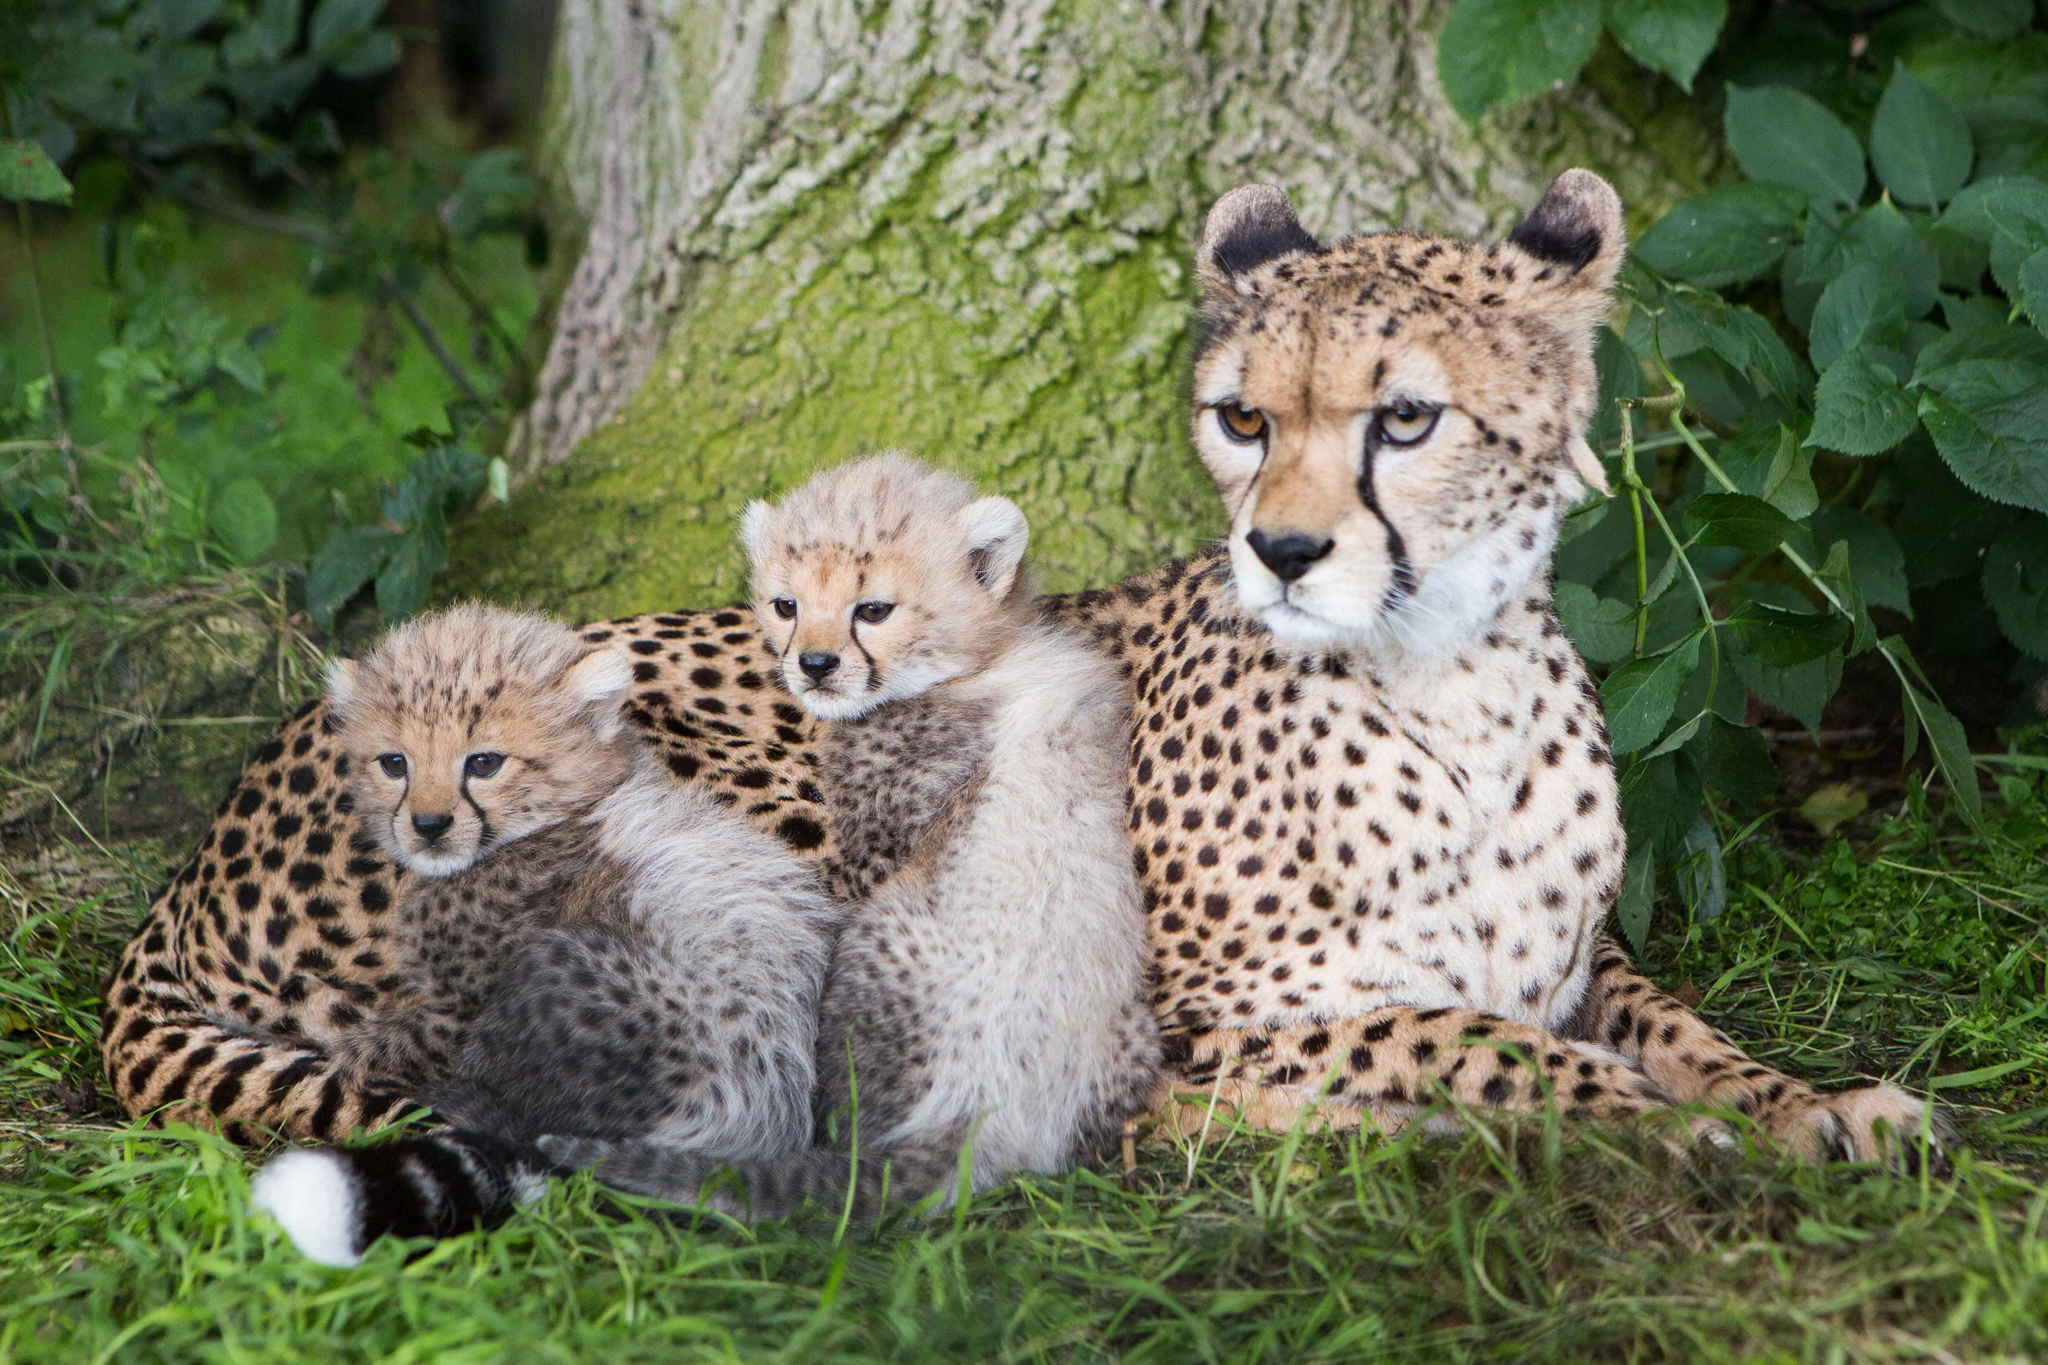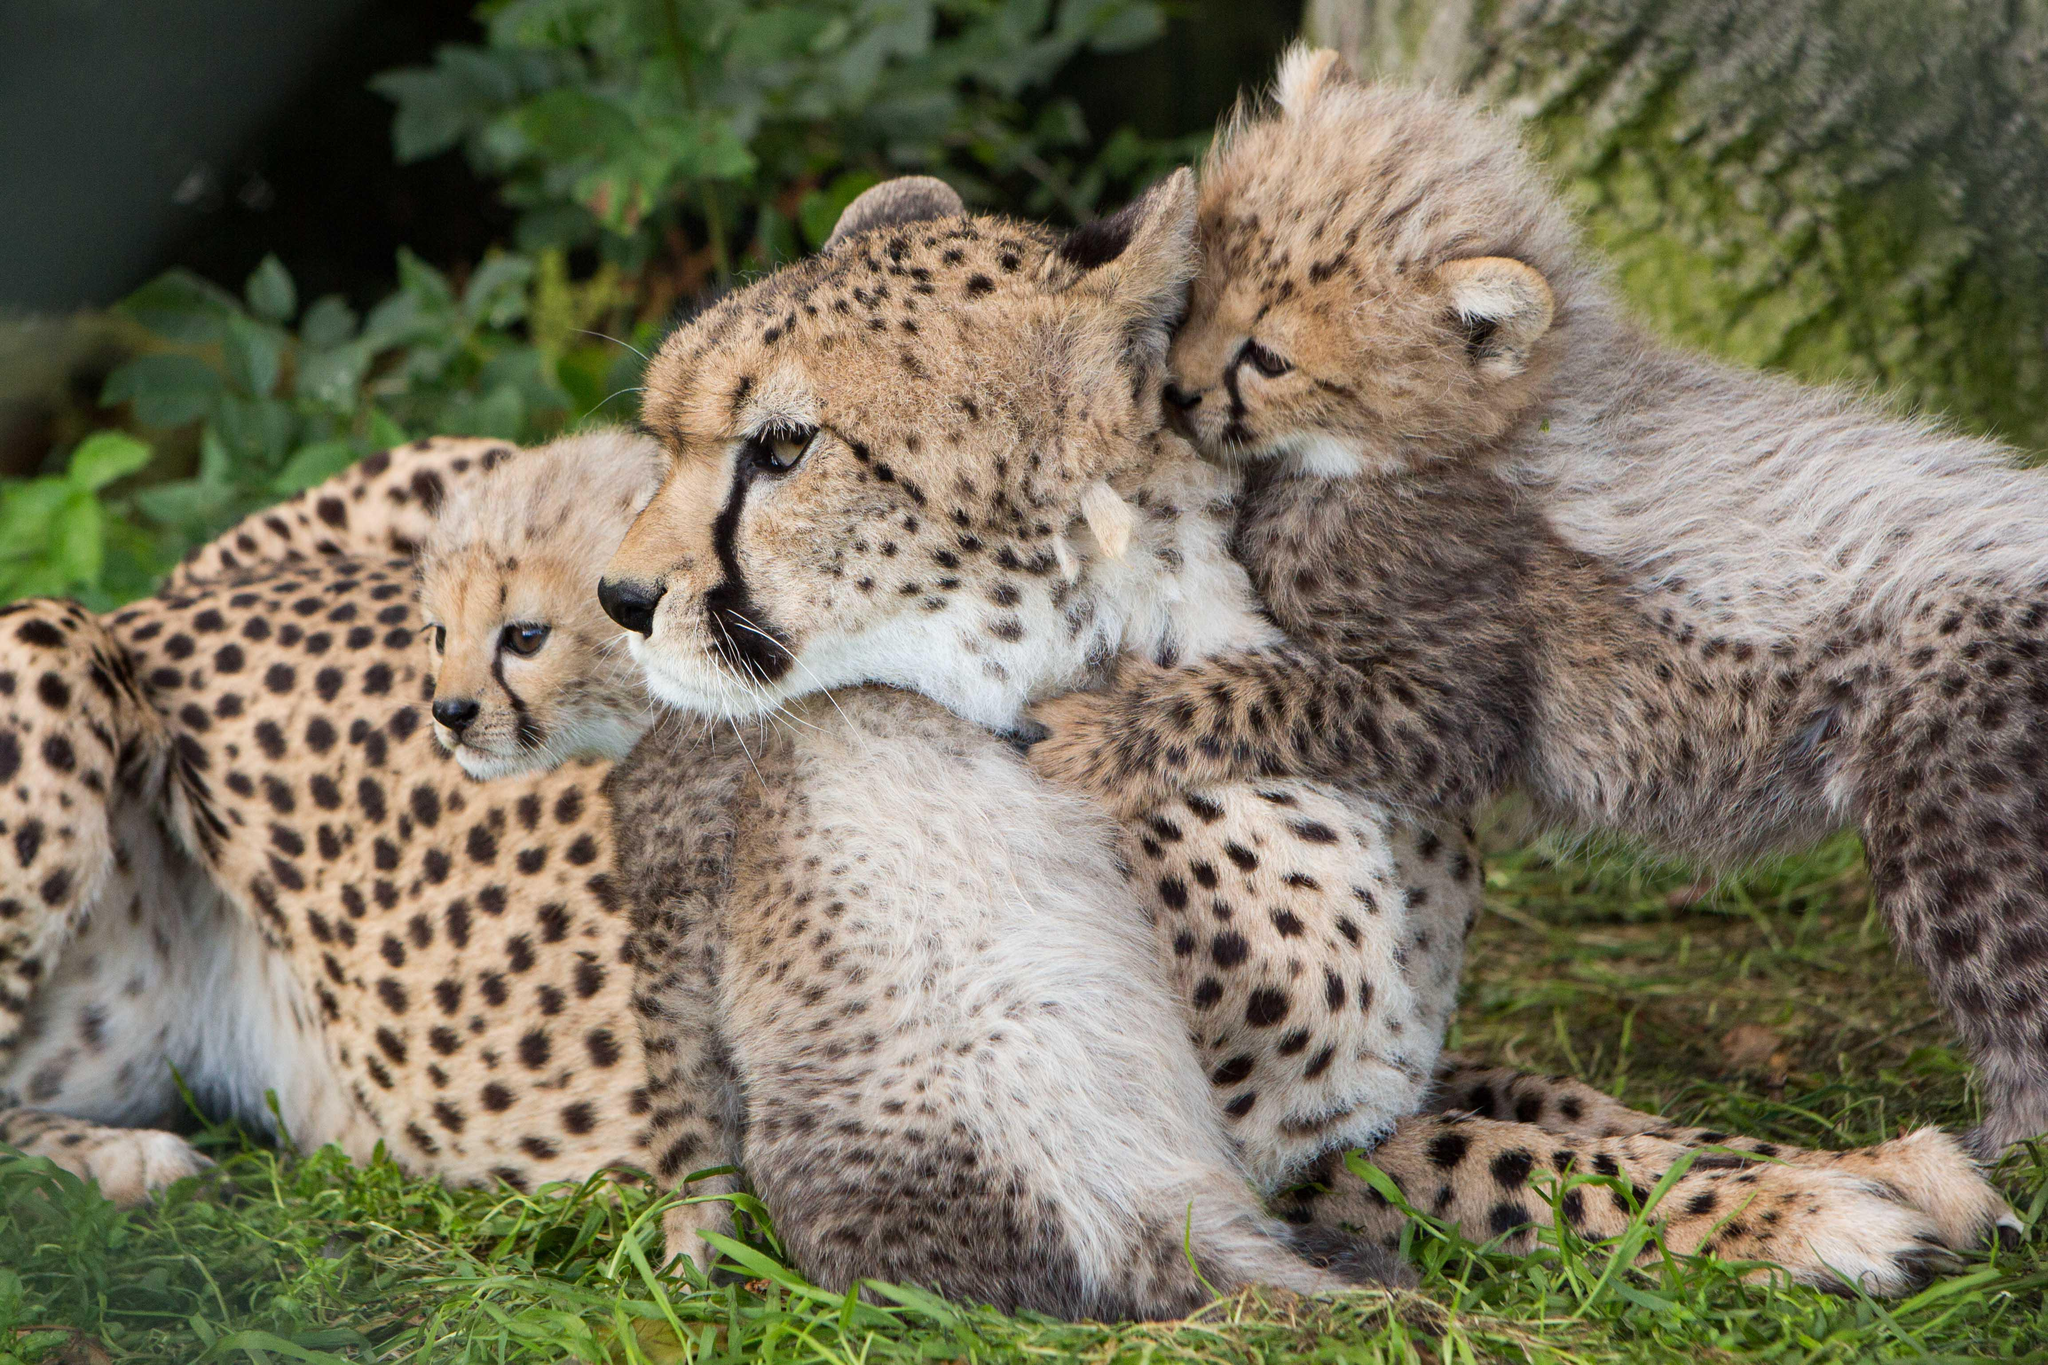The first image is the image on the left, the second image is the image on the right. Assess this claim about the two images: "the mother cheetah has two cubs next to her". Correct or not? Answer yes or no. Yes. The first image is the image on the left, the second image is the image on the right. Assess this claim about the two images: "The picture on the left shows at least two baby cheetah sitting down next to their mother.". Correct or not? Answer yes or no. Yes. 